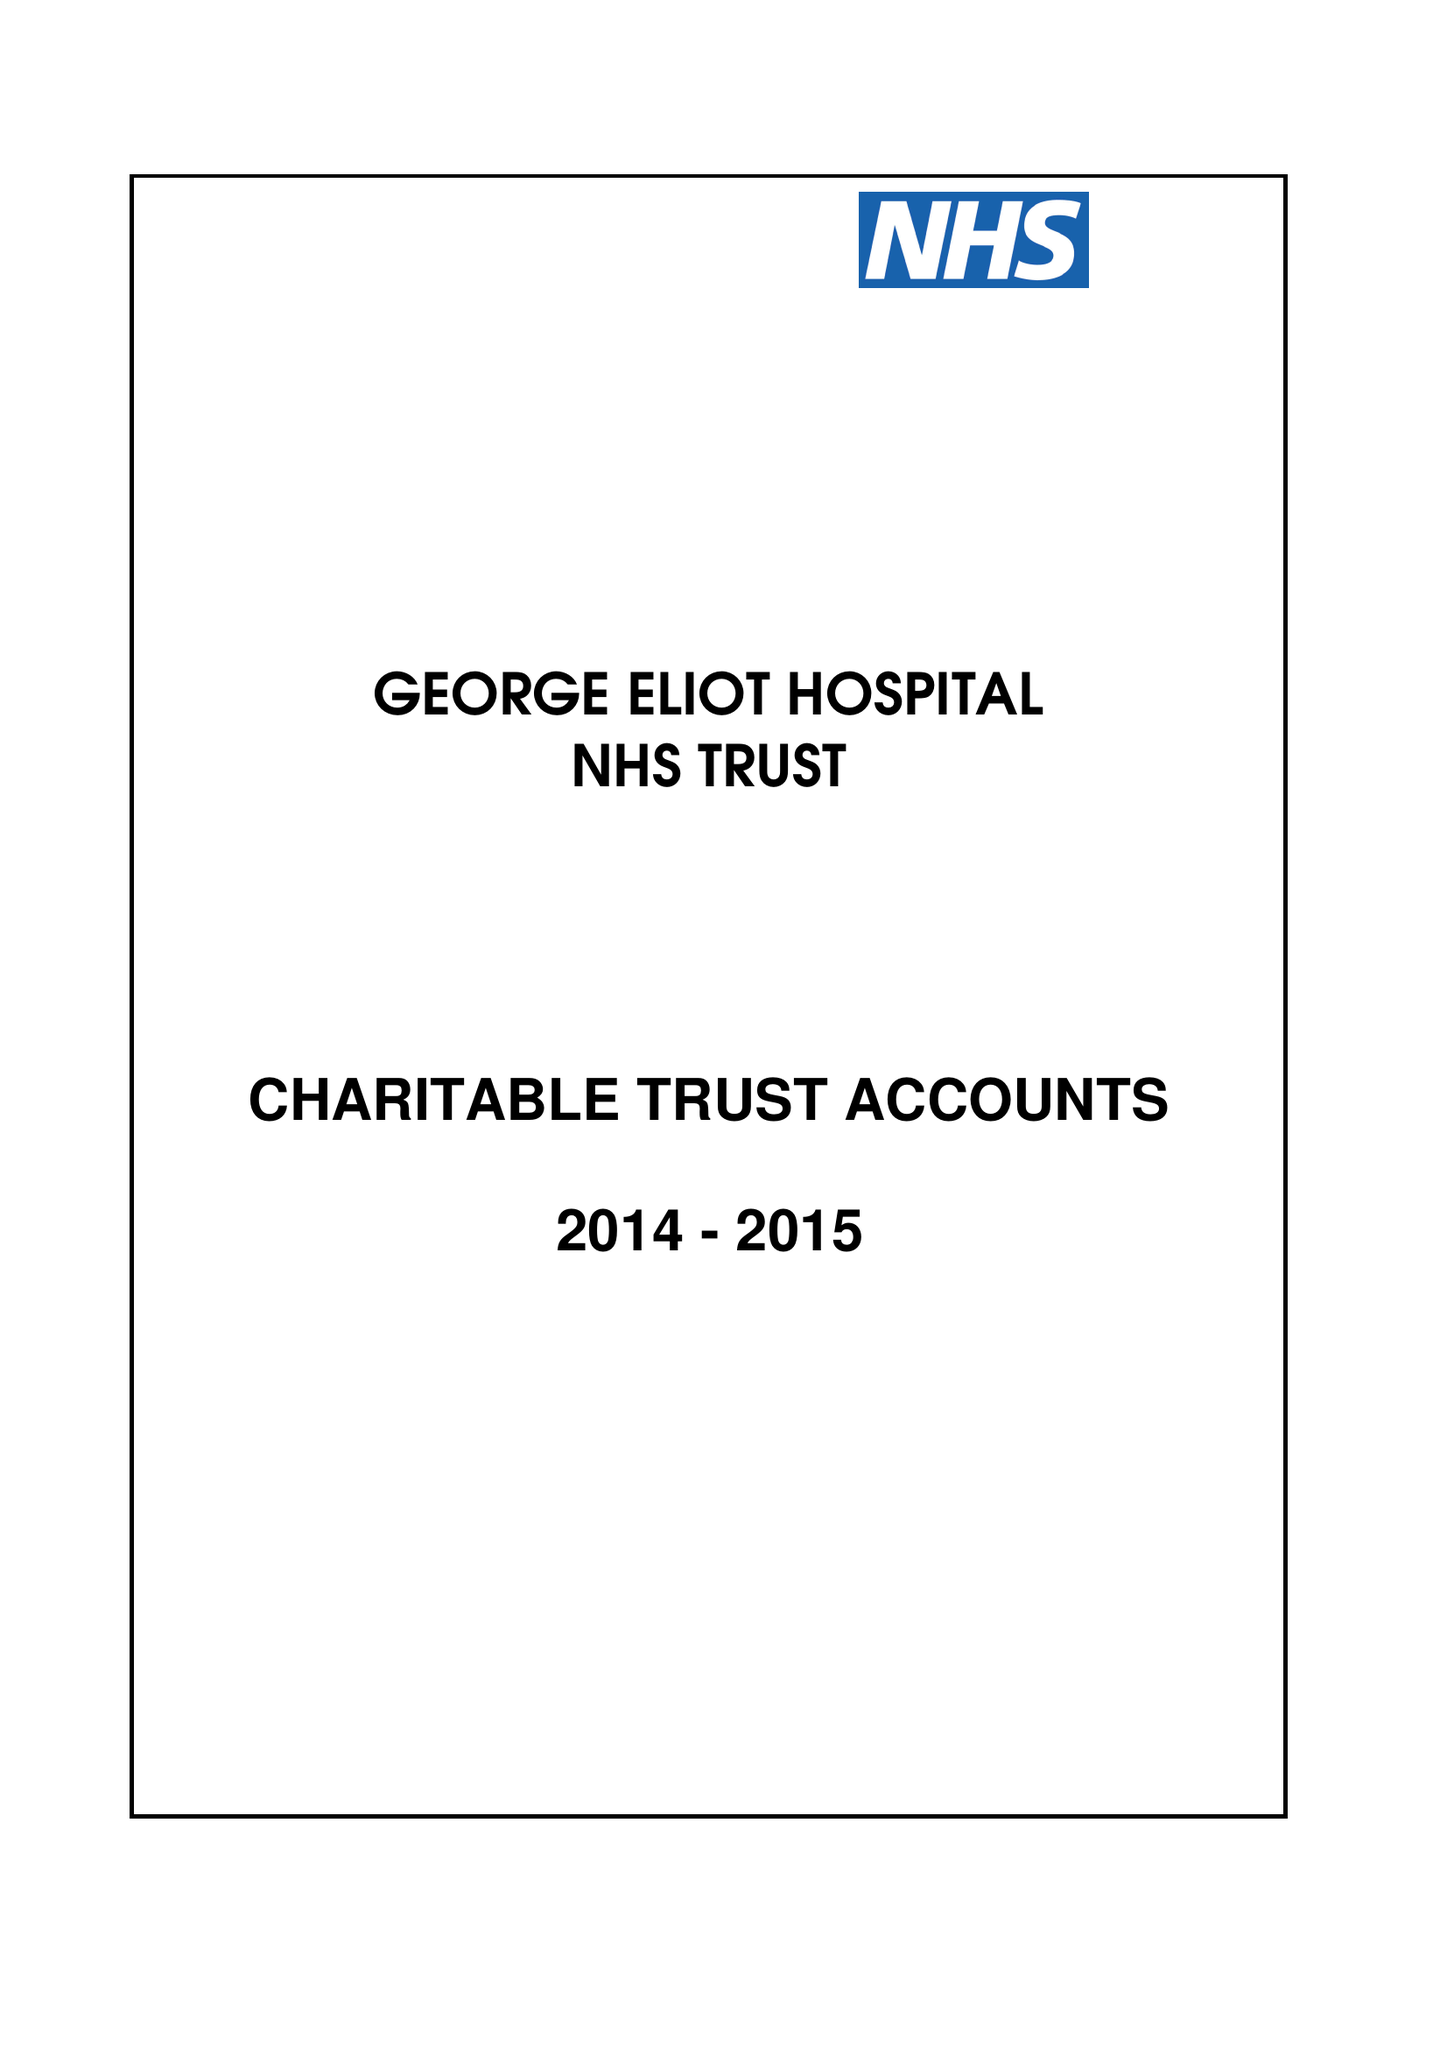What is the value for the address__post_town?
Answer the question using a single word or phrase. NUNEATON 